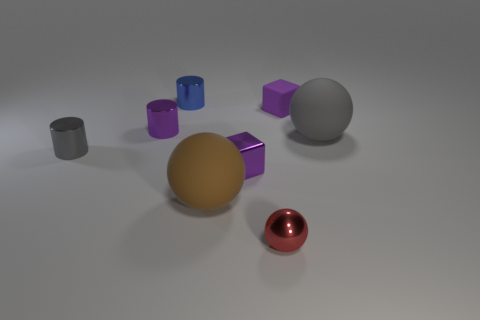How many other objects are there of the same size as the purple shiny cylinder?
Give a very brief answer. 5. There is a gray object on the right side of the blue metallic cylinder; what number of tiny purple cylinders are on the right side of it?
Ensure brevity in your answer.  0. Is the number of blue shiny cylinders that are on the right side of the red metallic sphere less than the number of red things?
Ensure brevity in your answer.  Yes. What is the shape of the small purple shiny thing behind the small purple metal object that is on the right side of the large rubber ball to the left of the tiny sphere?
Offer a very short reply. Cylinder. Do the red shiny object and the brown object have the same shape?
Offer a terse response. Yes. What number of other objects are the same shape as the small matte object?
Your response must be concise. 1. The matte ball that is the same size as the brown object is what color?
Make the answer very short. Gray. Is the number of tiny purple metallic things right of the brown matte thing the same as the number of purple cubes?
Make the answer very short. No. There is a shiny object that is to the right of the big brown thing and behind the tiny red metallic object; what shape is it?
Keep it short and to the point. Cube. Is the size of the gray metal cylinder the same as the gray rubber object?
Give a very brief answer. No. 